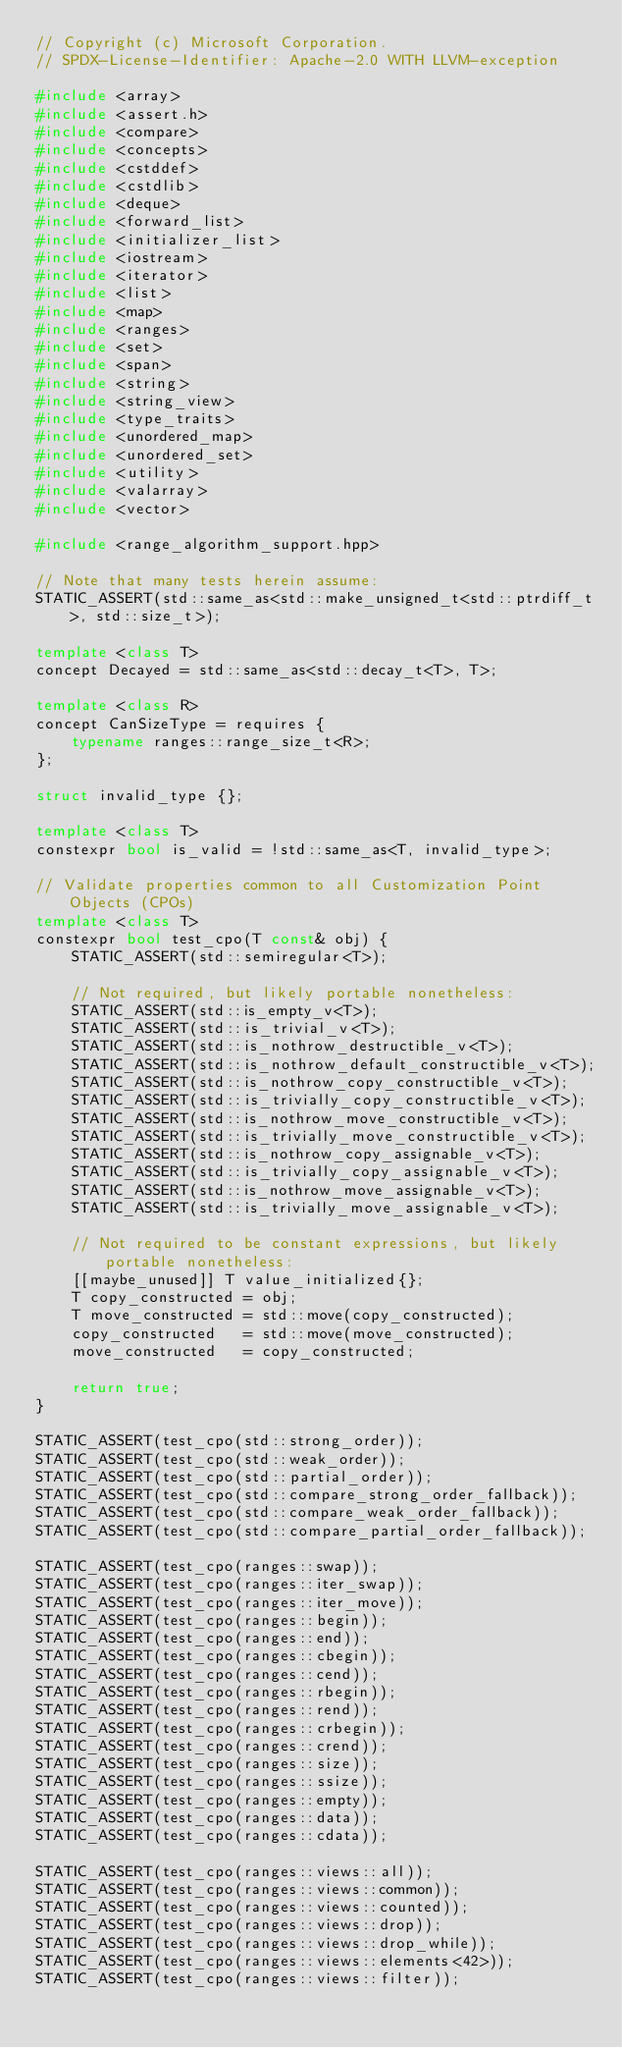Convert code to text. <code><loc_0><loc_0><loc_500><loc_500><_C++_>// Copyright (c) Microsoft Corporation.
// SPDX-License-Identifier: Apache-2.0 WITH LLVM-exception

#include <array>
#include <assert.h>
#include <compare>
#include <concepts>
#include <cstddef>
#include <cstdlib>
#include <deque>
#include <forward_list>
#include <initializer_list>
#include <iostream>
#include <iterator>
#include <list>
#include <map>
#include <ranges>
#include <set>
#include <span>
#include <string>
#include <string_view>
#include <type_traits>
#include <unordered_map>
#include <unordered_set>
#include <utility>
#include <valarray>
#include <vector>

#include <range_algorithm_support.hpp>

// Note that many tests herein assume:
STATIC_ASSERT(std::same_as<std::make_unsigned_t<std::ptrdiff_t>, std::size_t>);

template <class T>
concept Decayed = std::same_as<std::decay_t<T>, T>;

template <class R>
concept CanSizeType = requires {
    typename ranges::range_size_t<R>;
};

struct invalid_type {};

template <class T>
constexpr bool is_valid = !std::same_as<T, invalid_type>;

// Validate properties common to all Customization Point Objects (CPOs)
template <class T>
constexpr bool test_cpo(T const& obj) {
    STATIC_ASSERT(std::semiregular<T>);

    // Not required, but likely portable nonetheless:
    STATIC_ASSERT(std::is_empty_v<T>);
    STATIC_ASSERT(std::is_trivial_v<T>);
    STATIC_ASSERT(std::is_nothrow_destructible_v<T>);
    STATIC_ASSERT(std::is_nothrow_default_constructible_v<T>);
    STATIC_ASSERT(std::is_nothrow_copy_constructible_v<T>);
    STATIC_ASSERT(std::is_trivially_copy_constructible_v<T>);
    STATIC_ASSERT(std::is_nothrow_move_constructible_v<T>);
    STATIC_ASSERT(std::is_trivially_move_constructible_v<T>);
    STATIC_ASSERT(std::is_nothrow_copy_assignable_v<T>);
    STATIC_ASSERT(std::is_trivially_copy_assignable_v<T>);
    STATIC_ASSERT(std::is_nothrow_move_assignable_v<T>);
    STATIC_ASSERT(std::is_trivially_move_assignable_v<T>);

    // Not required to be constant expressions, but likely portable nonetheless:
    [[maybe_unused]] T value_initialized{};
    T copy_constructed = obj;
    T move_constructed = std::move(copy_constructed);
    copy_constructed   = std::move(move_constructed);
    move_constructed   = copy_constructed;

    return true;
}

STATIC_ASSERT(test_cpo(std::strong_order));
STATIC_ASSERT(test_cpo(std::weak_order));
STATIC_ASSERT(test_cpo(std::partial_order));
STATIC_ASSERT(test_cpo(std::compare_strong_order_fallback));
STATIC_ASSERT(test_cpo(std::compare_weak_order_fallback));
STATIC_ASSERT(test_cpo(std::compare_partial_order_fallback));

STATIC_ASSERT(test_cpo(ranges::swap));
STATIC_ASSERT(test_cpo(ranges::iter_swap));
STATIC_ASSERT(test_cpo(ranges::iter_move));
STATIC_ASSERT(test_cpo(ranges::begin));
STATIC_ASSERT(test_cpo(ranges::end));
STATIC_ASSERT(test_cpo(ranges::cbegin));
STATIC_ASSERT(test_cpo(ranges::cend));
STATIC_ASSERT(test_cpo(ranges::rbegin));
STATIC_ASSERT(test_cpo(ranges::rend));
STATIC_ASSERT(test_cpo(ranges::crbegin));
STATIC_ASSERT(test_cpo(ranges::crend));
STATIC_ASSERT(test_cpo(ranges::size));
STATIC_ASSERT(test_cpo(ranges::ssize));
STATIC_ASSERT(test_cpo(ranges::empty));
STATIC_ASSERT(test_cpo(ranges::data));
STATIC_ASSERT(test_cpo(ranges::cdata));

STATIC_ASSERT(test_cpo(ranges::views::all));
STATIC_ASSERT(test_cpo(ranges::views::common));
STATIC_ASSERT(test_cpo(ranges::views::counted));
STATIC_ASSERT(test_cpo(ranges::views::drop));
STATIC_ASSERT(test_cpo(ranges::views::drop_while));
STATIC_ASSERT(test_cpo(ranges::views::elements<42>));
STATIC_ASSERT(test_cpo(ranges::views::filter));</code> 